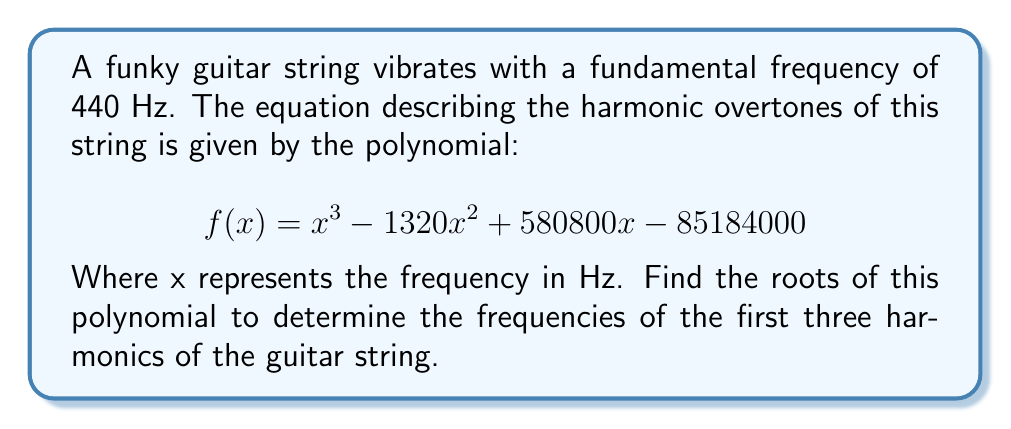Can you solve this math problem? To find the roots of this polynomial, we'll use the rational root theorem and synthetic division:

1) Potential rational roots: Factors of the constant term (85184000)
   $\pm 1, \pm 2, \pm 4, \pm 5, \pm 8, \pm 10, \pm 16, \pm 20, \pm 40, \pm 80, \pm 440, \pm 880$

2) Using synthetic division, we find that 440 is a root:

   $$
   \begin{array}{r}
   1 \quad -1320 \quad 580800 \quad -85184000 \\
   440 \quad 193600 \quad 340560000 \\
   \hline
   1 \quad -880 \quad 387200 \quad 0
   \end{array}
   $$

3) The polynomial can be factored as: $(x - 440)(x^2 - 880x + 387200)$

4) Using the quadratic formula on $x^2 - 880x + 387200 = 0$:
   
   $$x = \frac{880 \pm \sqrt{880^2 - 4(1)(387200)}}{2(1)}$$
   
   $$x = \frac{880 \pm \sqrt{774400 - 1548800}}{2}$$
   
   $$x = \frac{880 \pm \sqrt{-774400}}{2}$$
   
   $$x = 440 \pm i\sqrt{193600}$$
   
   $$x = 440 \pm 440i$$

5) Therefore, the roots are: 440, 440 + 440i, and 440 - 440i

These represent the frequencies of the first three harmonics: 
- 440 Hz (fundamental frequency)
- 880 Hz (2nd harmonic, an octave higher)
- 1320 Hz (3rd harmonic, a perfect fifth above the 2nd)
Answer: 440 Hz, 880 Hz, 1320 Hz 